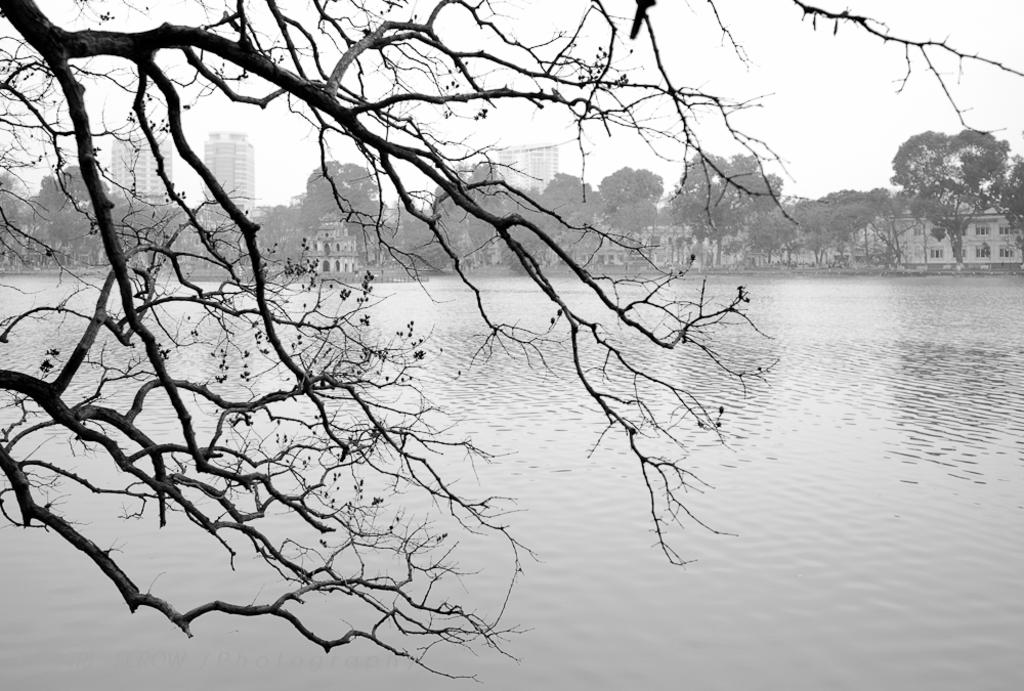What is visible in the image? There is water visible in the image. What is located in front of the water? There is a dried tree in front of the water. What can be seen in the background of the image? There are trees and buildings in the background of the image. What is the color of the sky in the image? The sky is white in color. Can you tell me how many giraffes are standing near the dried tree in the image? There are no giraffes present in the image; it only features a dried tree and water. What type of toothpaste is the grandfather using in the image? There is no grandfather or toothpaste present in the image. 